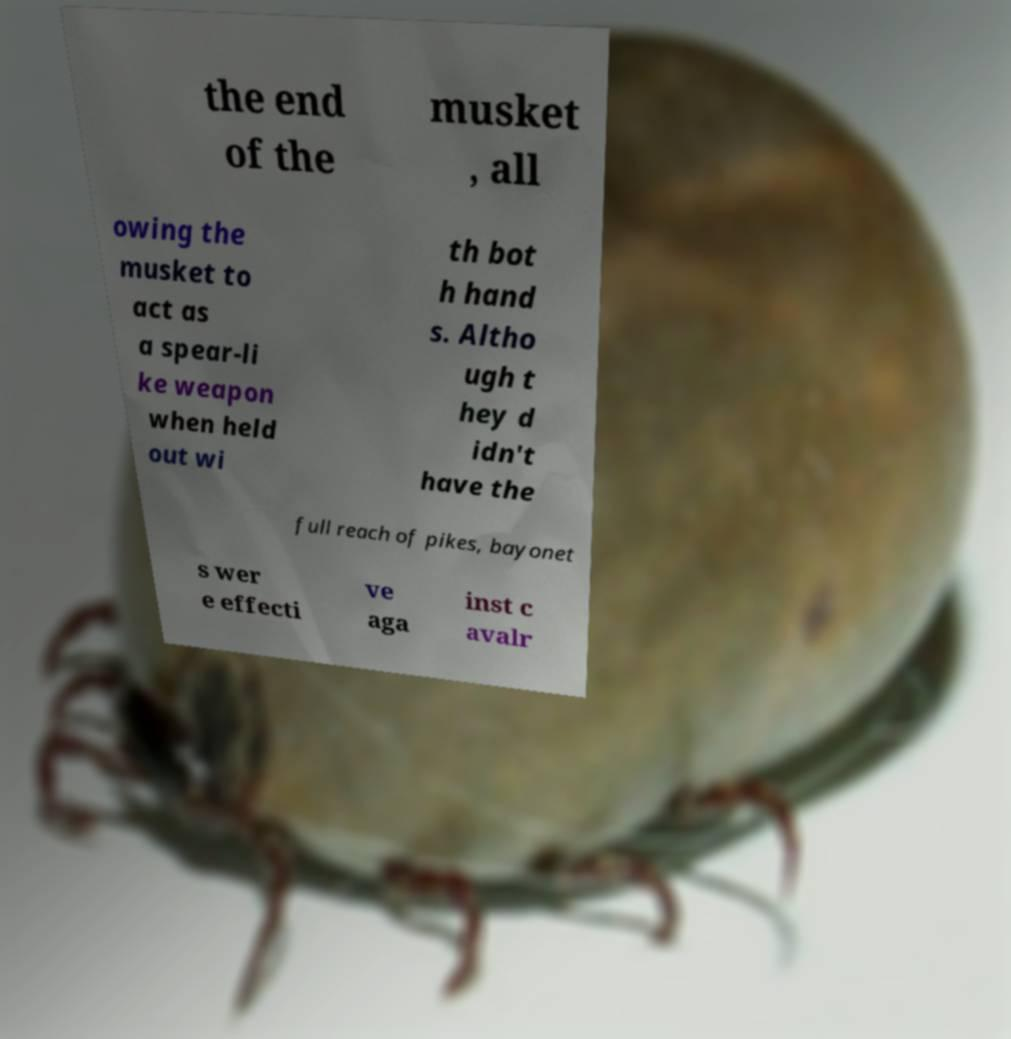Can you read and provide the text displayed in the image?This photo seems to have some interesting text. Can you extract and type it out for me? the end of the musket , all owing the musket to act as a spear-li ke weapon when held out wi th bot h hand s. Altho ugh t hey d idn't have the full reach of pikes, bayonet s wer e effecti ve aga inst c avalr 